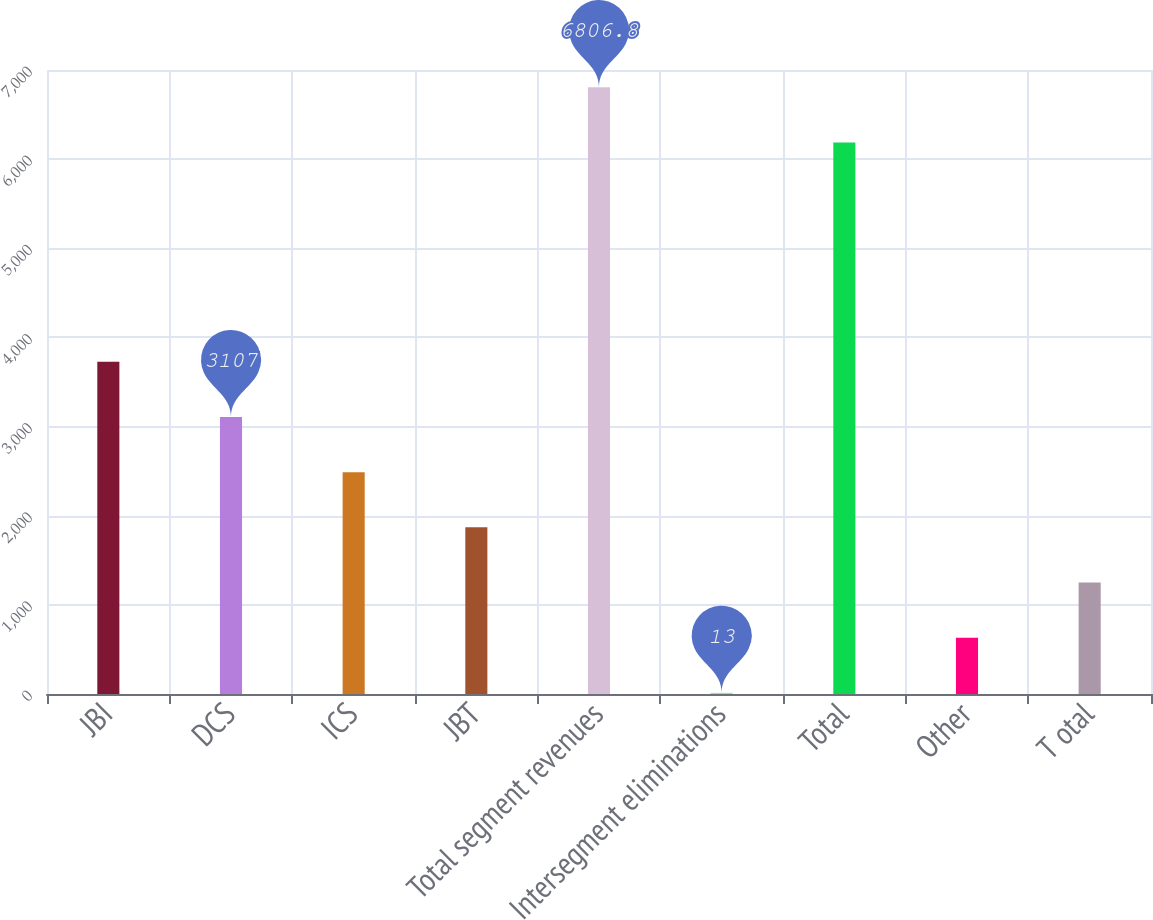<chart> <loc_0><loc_0><loc_500><loc_500><bar_chart><fcel>JBI<fcel>DCS<fcel>ICS<fcel>JBT<fcel>Total segment revenues<fcel>Intersegment eliminations<fcel>Total<fcel>Other<fcel>T otal<nl><fcel>3725.8<fcel>3107<fcel>2488.2<fcel>1869.4<fcel>6806.8<fcel>13<fcel>6188<fcel>631.8<fcel>1250.6<nl></chart> 